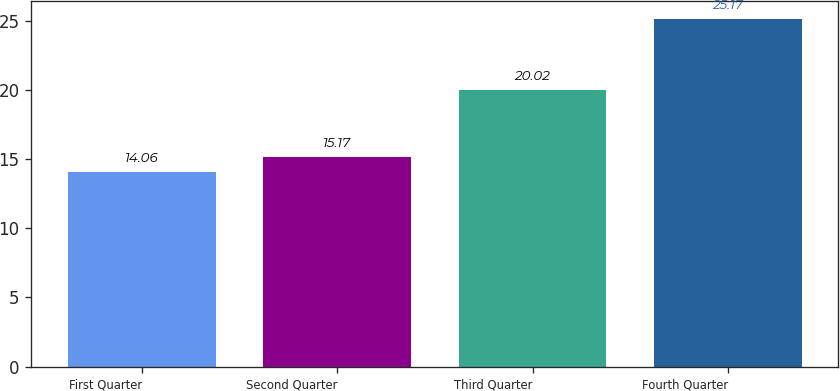Convert chart. <chart><loc_0><loc_0><loc_500><loc_500><bar_chart><fcel>First Quarter<fcel>Second Quarter<fcel>Third Quarter<fcel>Fourth Quarter<nl><fcel>14.06<fcel>15.17<fcel>20.02<fcel>25.17<nl></chart> 